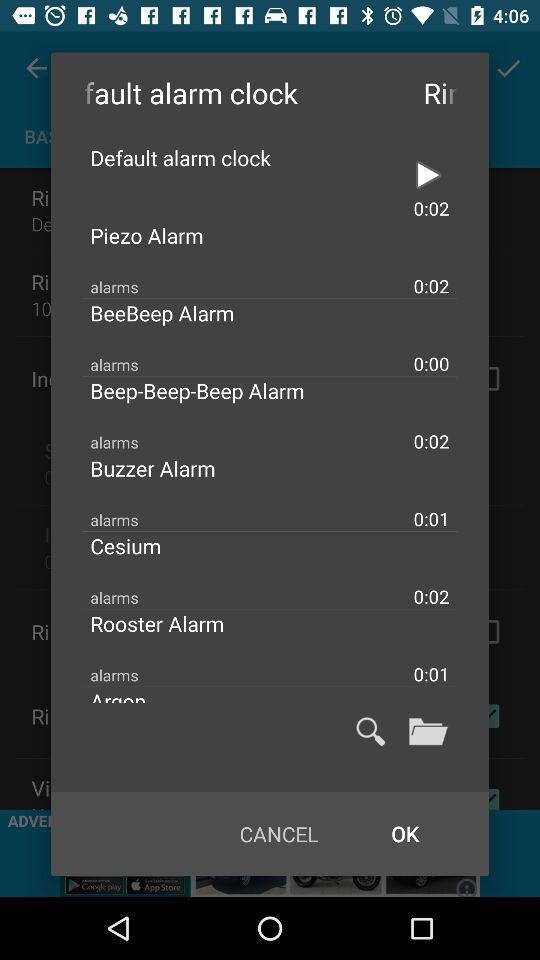What is the duration of the rooster alarm? The duration of the rooster alarm is "0:01". 